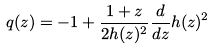<formula> <loc_0><loc_0><loc_500><loc_500>q ( z ) = - 1 + \frac { 1 + z } { 2 h ( z ) ^ { 2 } } \frac { d } { d z } h ( z ) ^ { 2 }</formula> 